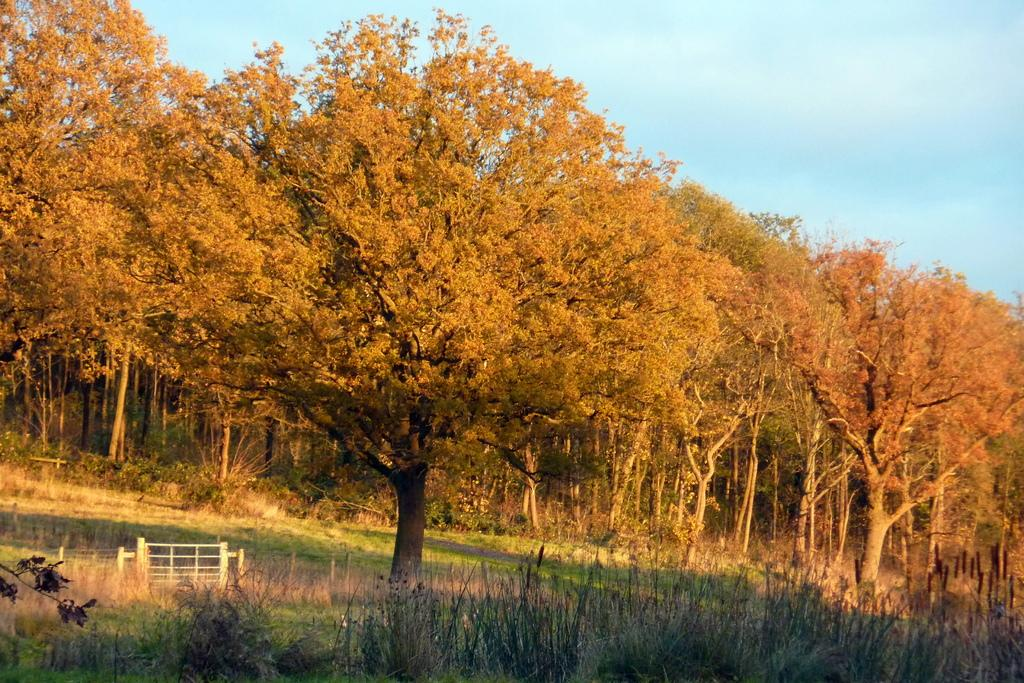What type of vegetation is present at the bottom of the image? There is grass on the ground at the bottom of the image. What can be seen in the background of the image? There are trees, plants, grass, and clouds visible in the background of the image. What is the reaction of the grass when it is pushed in the image? There is no indication in the image that the grass is being pushed, and therefore no reaction can be observed. 